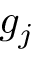<formula> <loc_0><loc_0><loc_500><loc_500>g _ { j }</formula> 